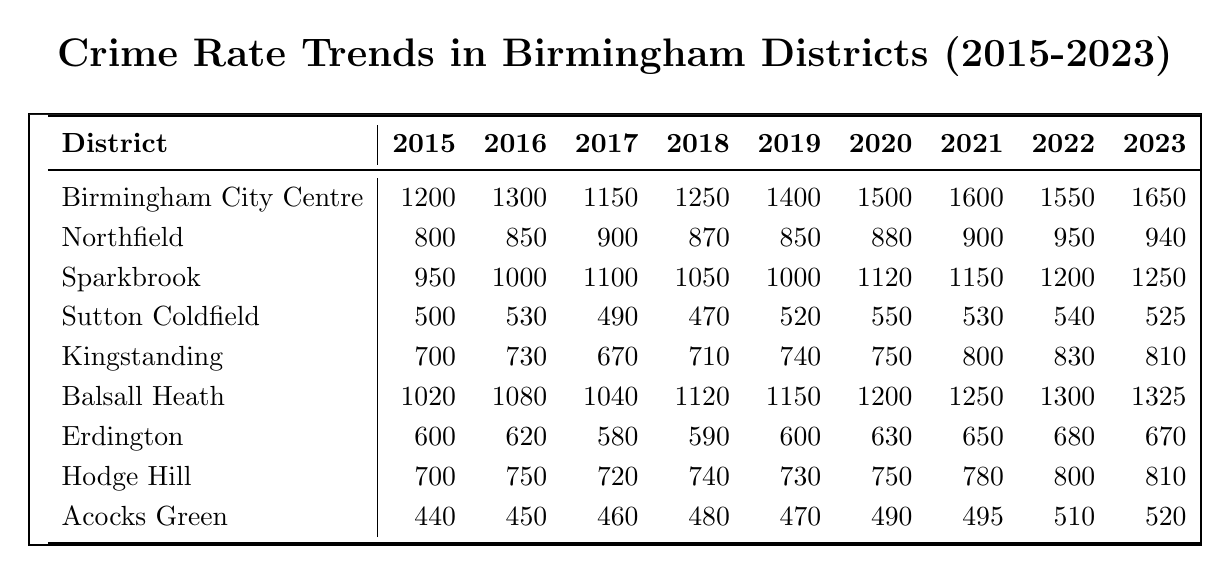What was the crime rate in Birmingham City Centre in 2020? The table shows that the crime rate in Birmingham City Centre in 2020 was 1500.
Answer: 1500 Which district had the lowest crime rate in 2015? From the table, Acocks Green had the lowest crime rate in 2015 at 440.
Answer: 440 What is the change in crime rate for Sutton Coldfield from 2015 to 2023? The crime rate in Sutton Coldfield in 2015 was 500 and in 2023 was 525. The change is 525 - 500 = 25.
Answer: 25 Did the crime rate in Northfield increase from 2015 to 2023? By comparing the values, Northfield's crime rate was 800 in 2015 and 940 in 2023, indicating an increase.
Answer: Yes Which district experienced the highest crime rate in 2022? Looking at the table, Birmingham City Centre had the highest crime rate in 2022 at 1550.
Answer: 1550 What is the average crime rate in Sparkbrook from 2015 to 2023? Summing the crime rates for Sparkbrook from 2015 (950) to 2023 (1250) gives: 950 + 1000 + 1100 + 1050 + 1000 + 1120 + 1150 + 1200 + 1250 = 10920. There are 9 years, so dividing: 10920 / 9 = 1213.33.
Answer: 1213.33 Is the crime rate for Balsall Heath consistently increasing from 2015 to 2023? Examining the rates, Balsall Heath increased from 1020 in 2015 to 1325 in 2023, but there are years where it decreased, for instance from 2021 to 2022.
Answer: No Which district had the greatest increase in crime rate from 2015 to 2023? Analyzing the rates, Birmingham City Centre's increase from 1200 in 2015 to 1650 in 2023 is the greatest, with an increase of 450.
Answer: Birmingham City Centre What was the total crime rate for Erdington from 2015 to 2023? Adding Erdington's values: 600 + 620 + 580 + 590 + 600 + 630 + 650 + 680 + 670 = 4620.
Answer: 4620 In which year did the crime rate in Hodge Hill experience its highest value? Looking through the data, Hodge Hill's highest crime rate of 810 occurred in both 2022 and 2023.
Answer: 2022 and 2023 